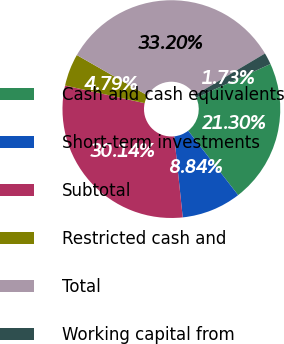<chart> <loc_0><loc_0><loc_500><loc_500><pie_chart><fcel>Cash and cash equivalents<fcel>Short-term investments<fcel>Subtotal<fcel>Restricted cash and<fcel>Total<fcel>Working capital from<nl><fcel>21.3%<fcel>8.84%<fcel>30.14%<fcel>4.79%<fcel>33.2%<fcel>1.73%<nl></chart> 